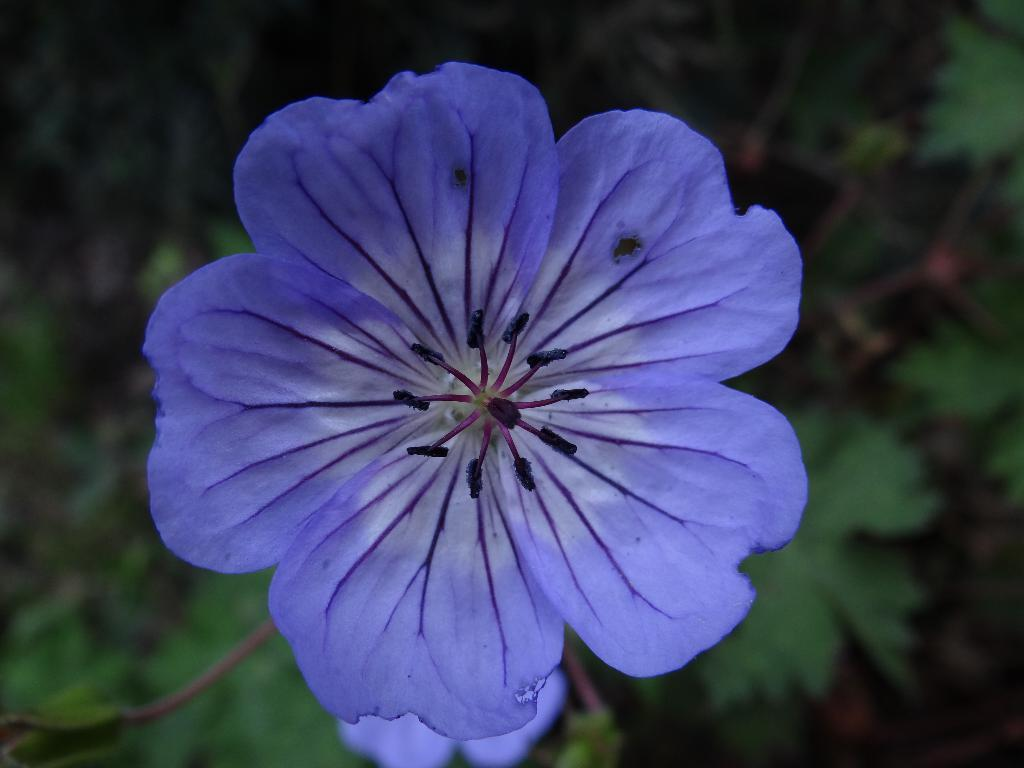What is the main subject in the front of the image? There is a flower in the front of the image. What can be seen in the background of the image? There are leaves visible in the background of the image. How many clocks are hanging on the tree in the image? There are no clocks present in the image; it features a flower and leaves. Are there any kittens playing on the slope in the image? There is no slope or kittens present in the image. 